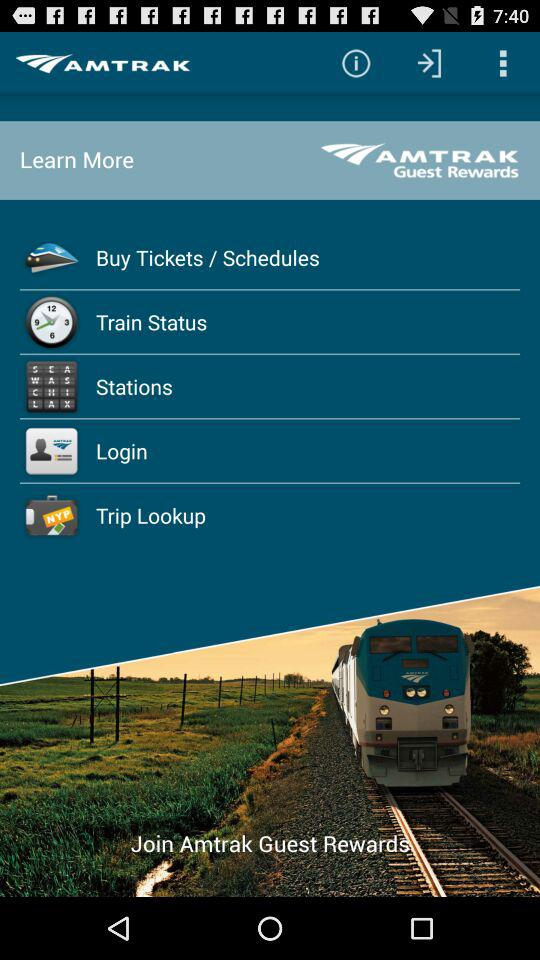What is the application name? The application name is "AMTRAK". 